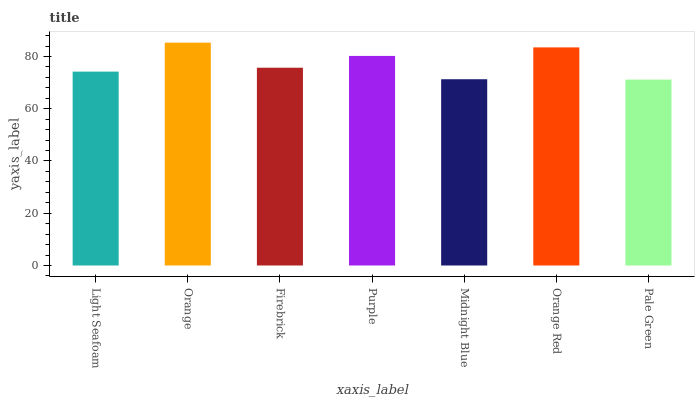Is Pale Green the minimum?
Answer yes or no. Yes. Is Orange the maximum?
Answer yes or no. Yes. Is Firebrick the minimum?
Answer yes or no. No. Is Firebrick the maximum?
Answer yes or no. No. Is Orange greater than Firebrick?
Answer yes or no. Yes. Is Firebrick less than Orange?
Answer yes or no. Yes. Is Firebrick greater than Orange?
Answer yes or no. No. Is Orange less than Firebrick?
Answer yes or no. No. Is Firebrick the high median?
Answer yes or no. Yes. Is Firebrick the low median?
Answer yes or no. Yes. Is Light Seafoam the high median?
Answer yes or no. No. Is Orange Red the low median?
Answer yes or no. No. 